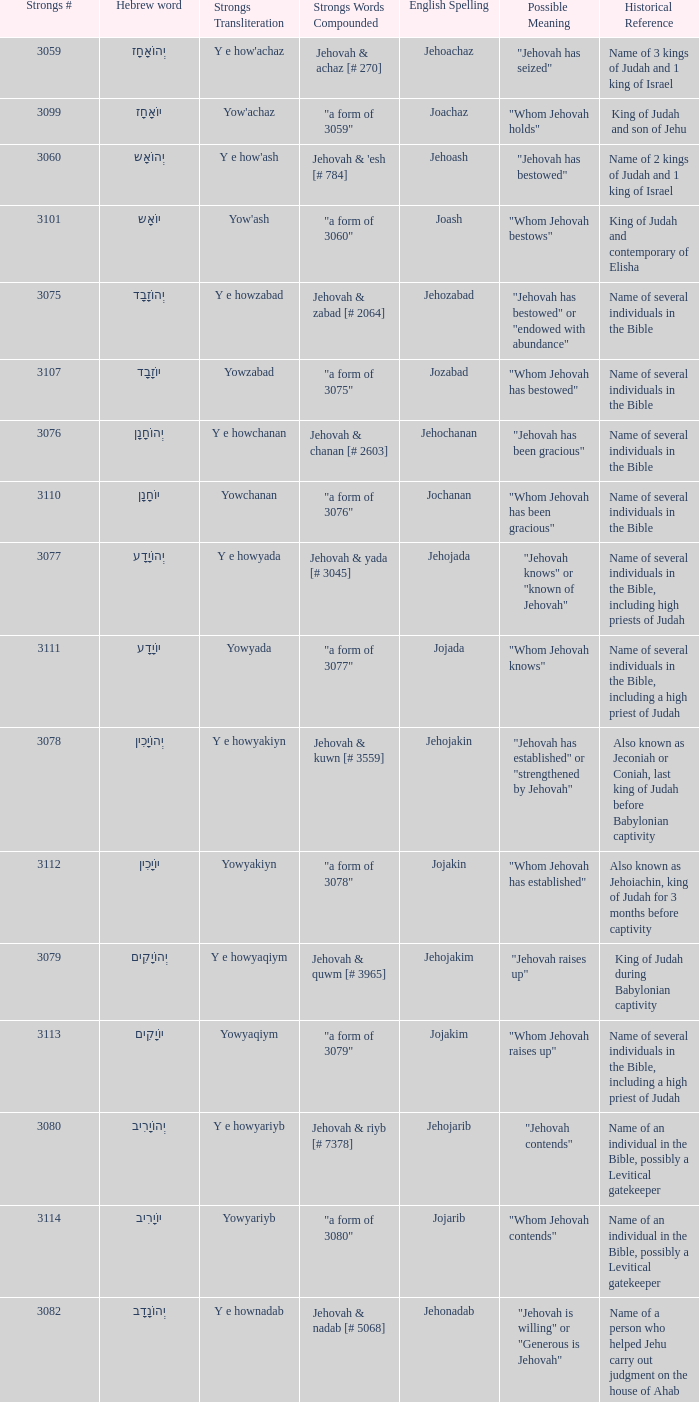What is the strongs transliteration of the hebrew word יוֹחָנָן? Yowchanan. Could you help me parse every detail presented in this table? {'header': ['Strongs #', 'Hebrew word', 'Strongs Transliteration', 'Strongs Words Compounded', 'English Spelling', 'Possible Meaning', 'Historical Reference'], 'rows': [['3059', 'יְהוֹאָחָז', "Y e how'achaz", 'Jehovah & achaz [# 270]', 'Jehoachaz', '"Jehovah has seized"', 'Name of 3 kings of Judah and 1 king of Israel'], ['3099', 'יוֹאָחָז', "Yow'achaz", '"a form of 3059"', 'Joachaz', '"Whom Jehovah holds"', 'King of Judah and son of Jehu'], ['3060', 'יְהוֹאָש', "Y e how'ash", "Jehovah & 'esh [# 784]", 'Jehoash', '"Jehovah has bestowed"', 'Name of 2 kings of Judah and 1 king of Israel'], ['3101', 'יוֹאָש', "Yow'ash", '"a form of 3060"', 'Joash', '"Whom Jehovah bestows"', 'King of Judah and contemporary of Elisha'], ['3075', 'יְהוֹזָבָד', 'Y e howzabad', 'Jehovah & zabad [# 2064]', 'Jehozabad', '"Jehovah has bestowed" or "endowed with abundance"', 'Name of several individuals in the Bible'], ['3107', 'יוֹזָבָד', 'Yowzabad', '"a form of 3075"', 'Jozabad', '"Whom Jehovah has bestowed"', 'Name of several individuals in the Bible'], ['3076', 'יְהוֹחָנָן', 'Y e howchanan', 'Jehovah & chanan [# 2603]', 'Jehochanan', '"Jehovah has been gracious"', 'Name of several individuals in the Bible'], ['3110', 'יוֹחָנָן', 'Yowchanan', '"a form of 3076"', 'Jochanan', '"Whom Jehovah has been gracious"', 'Name of several individuals in the Bible'], ['3077', 'יְהוֹיָדָע', 'Y e howyada', 'Jehovah & yada [# 3045]', 'Jehojada', '"Jehovah knows" or "known of Jehovah"', 'Name of several individuals in the Bible, including high priests of Judah'], ['3111', 'יוֹיָדָע', 'Yowyada', '"a form of 3077"', 'Jojada', '"Whom Jehovah knows"', 'Name of several individuals in the Bible, including a high priest of Judah'], ['3078', 'יְהוֹיָכִין', 'Y e howyakiyn', 'Jehovah & kuwn [# 3559]', 'Jehojakin', '"Jehovah has established" or "strengthened by Jehovah"', 'Also known as Jeconiah or Coniah, last king of Judah before Babylonian captivity'], ['3112', 'יוֹיָכִין', 'Yowyakiyn', '"a form of 3078"', 'Jojakin', '"Whom Jehovah has established"', 'Also known as Jehoiachin, king of Judah for 3 months before captivity'], ['3079', 'יְהוֹיָקִים', 'Y e howyaqiym', 'Jehovah & quwm [# 3965]', 'Jehojakim', '"Jehovah raises up"', 'King of Judah during Babylonian captivity'], ['3113', 'יוֹיָקִים', 'Yowyaqiym', '"a form of 3079"', 'Jojakim', '"Whom Jehovah raises up"', 'Name of several individuals in the Bible, including a high priest of Judah'], ['3080', 'יְהוֹיָרִיב', 'Y e howyariyb', 'Jehovah & riyb [# 7378]', 'Jehojarib', '"Jehovah contends"', 'Name of an individual in the Bible, possibly a Levitical gatekeeper'], ['3114', 'יוֹיָרִיב', 'Yowyariyb', '"a form of 3080"', 'Jojarib', '"Whom Jehovah contends"', 'Name of an individual in the Bible, possibly a Levitical gatekeeper'], ['3082', 'יְהוֹנָדָב', 'Y e hownadab', 'Jehovah & nadab [# 5068]', 'Jehonadab', '"Jehovah is willing" or "Generous is Jehovah"', 'Name of a person who helped Jehu carry out judgment on the house of Ahab'], ['3122', 'יוֹנָדָב', 'Yownadab', '"a form of 3082"', 'Jonadab', '"Whom God is willing"', 'Bible character who was praised for his faithfulness to his family traditions'], ['3083', 'יְהוֹנָתָן', 'Y e hownathan', 'Jehovah & nathan [# 5414]', 'Jehonathan', '"Jehovah has given"', 'Name of son of king Saul and close friend of David'], ['3129', 'יוֹנָתָן', 'Yownathan', '"a form of 3083"', 'Jonathan', '"Whom Jehovah has given"', 'Name of several individuals in the Bible'], ['3085', 'יְהוֹעַדָּה', "Y e how'addah", "Jehovah & 'adah [# 5710]", 'Jehoaddah', '"Jehovah has adorned" or "adorned by Jehovah"', 'Name of a woman mentioned in King James Version (KJV) Bible'], ['3087', 'יְהוֹצָדָק', 'Y e howtsadaq', 'Jehovah & tsadaq [# 6663]', 'Jehotsadak', '"Jehovah is righteous" or "Righteousness of Jehovah"', 'High priest who helped lead the rebuilding of the temple under Zerubbabel after Babylonian exile'], ['3136', 'יוֹצָדָק', 'Yowtsadaq', '"a form of 3087"', 'Jotsadak', '"Whom Jehovah is righteous"', 'Name of several individuals in the Bible'], ['3088', 'יְהוֹרָם', 'Y e howram', 'Jehovah & ruwm [# 7311]', 'Jehoram', '"Jehovah is exalted"', 'Name of 2 kings of Judah and 1 king of Israel in the Old Testament'], ['3141', 'יוֹרָם', 'Yowram', '"a form of 3088"', 'Joram', '"Whom Jehovah exalts"', 'Name of several individuals in the Bible'], ['3092', 'יְהוֹשָפָט', 'Y e howshaphat', 'Jehovah & shaphat [# 8199]', 'Jehoshaphat', '"Jehovah has judged"', 'King of Judah who is noted for his reforms and battles against neighboring nations.']]} 